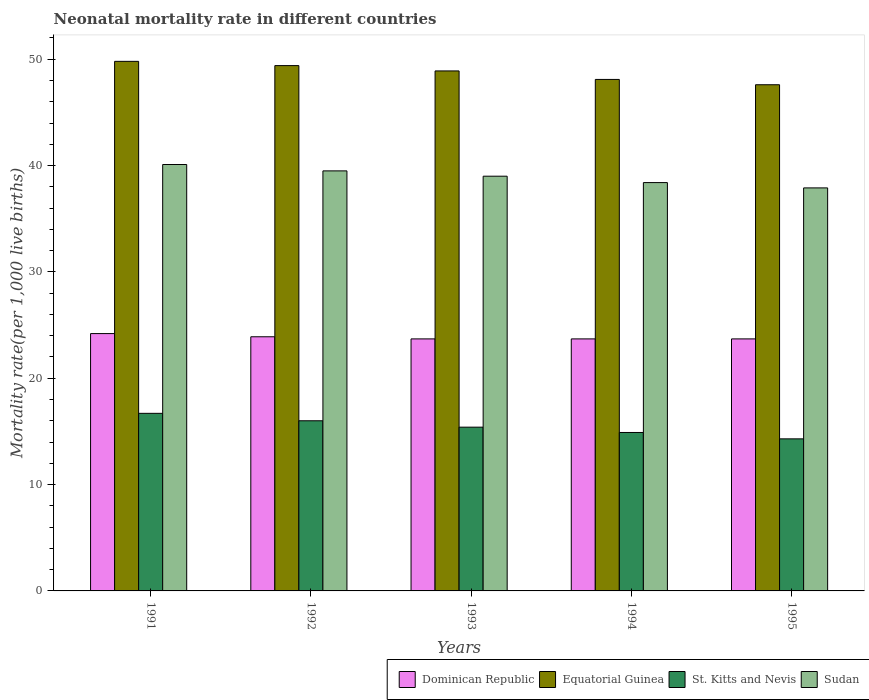How many bars are there on the 2nd tick from the left?
Ensure brevity in your answer.  4. In how many cases, is the number of bars for a given year not equal to the number of legend labels?
Your answer should be compact. 0. What is the neonatal mortality rate in Sudan in 1994?
Make the answer very short. 38.4. Across all years, what is the maximum neonatal mortality rate in Sudan?
Ensure brevity in your answer.  40.1. Across all years, what is the minimum neonatal mortality rate in Equatorial Guinea?
Offer a very short reply. 47.6. In which year was the neonatal mortality rate in St. Kitts and Nevis minimum?
Make the answer very short. 1995. What is the total neonatal mortality rate in Equatorial Guinea in the graph?
Make the answer very short. 243.8. What is the difference between the neonatal mortality rate in St. Kitts and Nevis in 1992 and that in 1995?
Offer a terse response. 1.7. What is the difference between the neonatal mortality rate in Sudan in 1991 and the neonatal mortality rate in Equatorial Guinea in 1994?
Provide a short and direct response. -8. What is the average neonatal mortality rate in Sudan per year?
Provide a succinct answer. 38.98. In the year 1993, what is the difference between the neonatal mortality rate in Dominican Republic and neonatal mortality rate in Equatorial Guinea?
Provide a short and direct response. -25.2. In how many years, is the neonatal mortality rate in Sudan greater than 28?
Your response must be concise. 5. What is the ratio of the neonatal mortality rate in Equatorial Guinea in 1992 to that in 1993?
Give a very brief answer. 1.01. Is the neonatal mortality rate in Dominican Republic in 1991 less than that in 1993?
Your answer should be very brief. No. What is the difference between the highest and the second highest neonatal mortality rate in Sudan?
Your response must be concise. 0.6. What is the difference between the highest and the lowest neonatal mortality rate in Sudan?
Keep it short and to the point. 2.2. Is the sum of the neonatal mortality rate in Dominican Republic in 1993 and 1994 greater than the maximum neonatal mortality rate in St. Kitts and Nevis across all years?
Provide a short and direct response. Yes. Is it the case that in every year, the sum of the neonatal mortality rate in St. Kitts and Nevis and neonatal mortality rate in Sudan is greater than the sum of neonatal mortality rate in Dominican Republic and neonatal mortality rate in Equatorial Guinea?
Your answer should be very brief. No. What does the 4th bar from the left in 1995 represents?
Give a very brief answer. Sudan. What does the 2nd bar from the right in 1995 represents?
Offer a very short reply. St. Kitts and Nevis. How many bars are there?
Ensure brevity in your answer.  20. Are all the bars in the graph horizontal?
Give a very brief answer. No. Does the graph contain any zero values?
Provide a short and direct response. No. Does the graph contain grids?
Your response must be concise. No. Where does the legend appear in the graph?
Your answer should be compact. Bottom right. What is the title of the graph?
Your answer should be compact. Neonatal mortality rate in different countries. Does "Sint Maarten (Dutch part)" appear as one of the legend labels in the graph?
Your answer should be compact. No. What is the label or title of the Y-axis?
Your response must be concise. Mortality rate(per 1,0 live births). What is the Mortality rate(per 1,000 live births) of Dominican Republic in 1991?
Keep it short and to the point. 24.2. What is the Mortality rate(per 1,000 live births) of Equatorial Guinea in 1991?
Make the answer very short. 49.8. What is the Mortality rate(per 1,000 live births) of Sudan in 1991?
Your response must be concise. 40.1. What is the Mortality rate(per 1,000 live births) of Dominican Republic in 1992?
Give a very brief answer. 23.9. What is the Mortality rate(per 1,000 live births) of Equatorial Guinea in 1992?
Your answer should be very brief. 49.4. What is the Mortality rate(per 1,000 live births) in St. Kitts and Nevis in 1992?
Your response must be concise. 16. What is the Mortality rate(per 1,000 live births) of Sudan in 1992?
Your answer should be very brief. 39.5. What is the Mortality rate(per 1,000 live births) in Dominican Republic in 1993?
Your answer should be compact. 23.7. What is the Mortality rate(per 1,000 live births) in Equatorial Guinea in 1993?
Give a very brief answer. 48.9. What is the Mortality rate(per 1,000 live births) of Dominican Republic in 1994?
Make the answer very short. 23.7. What is the Mortality rate(per 1,000 live births) in Equatorial Guinea in 1994?
Ensure brevity in your answer.  48.1. What is the Mortality rate(per 1,000 live births) of St. Kitts and Nevis in 1994?
Keep it short and to the point. 14.9. What is the Mortality rate(per 1,000 live births) in Sudan in 1994?
Offer a terse response. 38.4. What is the Mortality rate(per 1,000 live births) in Dominican Republic in 1995?
Keep it short and to the point. 23.7. What is the Mortality rate(per 1,000 live births) of Equatorial Guinea in 1995?
Your answer should be compact. 47.6. What is the Mortality rate(per 1,000 live births) of St. Kitts and Nevis in 1995?
Make the answer very short. 14.3. What is the Mortality rate(per 1,000 live births) in Sudan in 1995?
Your answer should be very brief. 37.9. Across all years, what is the maximum Mortality rate(per 1,000 live births) of Dominican Republic?
Offer a terse response. 24.2. Across all years, what is the maximum Mortality rate(per 1,000 live births) in Equatorial Guinea?
Give a very brief answer. 49.8. Across all years, what is the maximum Mortality rate(per 1,000 live births) in St. Kitts and Nevis?
Give a very brief answer. 16.7. Across all years, what is the maximum Mortality rate(per 1,000 live births) of Sudan?
Your answer should be very brief. 40.1. Across all years, what is the minimum Mortality rate(per 1,000 live births) in Dominican Republic?
Ensure brevity in your answer.  23.7. Across all years, what is the minimum Mortality rate(per 1,000 live births) in Equatorial Guinea?
Provide a succinct answer. 47.6. Across all years, what is the minimum Mortality rate(per 1,000 live births) of Sudan?
Give a very brief answer. 37.9. What is the total Mortality rate(per 1,000 live births) in Dominican Republic in the graph?
Make the answer very short. 119.2. What is the total Mortality rate(per 1,000 live births) in Equatorial Guinea in the graph?
Provide a short and direct response. 243.8. What is the total Mortality rate(per 1,000 live births) of St. Kitts and Nevis in the graph?
Your answer should be very brief. 77.3. What is the total Mortality rate(per 1,000 live births) of Sudan in the graph?
Provide a succinct answer. 194.9. What is the difference between the Mortality rate(per 1,000 live births) in Dominican Republic in 1991 and that in 1992?
Provide a succinct answer. 0.3. What is the difference between the Mortality rate(per 1,000 live births) in St. Kitts and Nevis in 1991 and that in 1992?
Provide a succinct answer. 0.7. What is the difference between the Mortality rate(per 1,000 live births) of Dominican Republic in 1991 and that in 1993?
Your response must be concise. 0.5. What is the difference between the Mortality rate(per 1,000 live births) of St. Kitts and Nevis in 1991 and that in 1993?
Offer a very short reply. 1.3. What is the difference between the Mortality rate(per 1,000 live births) of Dominican Republic in 1991 and that in 1994?
Provide a succinct answer. 0.5. What is the difference between the Mortality rate(per 1,000 live births) in St. Kitts and Nevis in 1991 and that in 1994?
Offer a terse response. 1.8. What is the difference between the Mortality rate(per 1,000 live births) of Dominican Republic in 1991 and that in 1995?
Your answer should be very brief. 0.5. What is the difference between the Mortality rate(per 1,000 live births) of Equatorial Guinea in 1991 and that in 1995?
Ensure brevity in your answer.  2.2. What is the difference between the Mortality rate(per 1,000 live births) in St. Kitts and Nevis in 1991 and that in 1995?
Your answer should be very brief. 2.4. What is the difference between the Mortality rate(per 1,000 live births) of Dominican Republic in 1992 and that in 1993?
Provide a short and direct response. 0.2. What is the difference between the Mortality rate(per 1,000 live births) in Equatorial Guinea in 1992 and that in 1993?
Give a very brief answer. 0.5. What is the difference between the Mortality rate(per 1,000 live births) of Dominican Republic in 1992 and that in 1994?
Ensure brevity in your answer.  0.2. What is the difference between the Mortality rate(per 1,000 live births) of Equatorial Guinea in 1992 and that in 1994?
Give a very brief answer. 1.3. What is the difference between the Mortality rate(per 1,000 live births) of Sudan in 1992 and that in 1994?
Offer a very short reply. 1.1. What is the difference between the Mortality rate(per 1,000 live births) of Equatorial Guinea in 1992 and that in 1995?
Offer a terse response. 1.8. What is the difference between the Mortality rate(per 1,000 live births) of St. Kitts and Nevis in 1992 and that in 1995?
Offer a very short reply. 1.7. What is the difference between the Mortality rate(per 1,000 live births) of Sudan in 1992 and that in 1995?
Give a very brief answer. 1.6. What is the difference between the Mortality rate(per 1,000 live births) in Equatorial Guinea in 1993 and that in 1994?
Offer a very short reply. 0.8. What is the difference between the Mortality rate(per 1,000 live births) of St. Kitts and Nevis in 1993 and that in 1994?
Offer a terse response. 0.5. What is the difference between the Mortality rate(per 1,000 live births) of Sudan in 1993 and that in 1994?
Your response must be concise. 0.6. What is the difference between the Mortality rate(per 1,000 live births) in Dominican Republic in 1993 and that in 1995?
Keep it short and to the point. 0. What is the difference between the Mortality rate(per 1,000 live births) of Sudan in 1993 and that in 1995?
Offer a terse response. 1.1. What is the difference between the Mortality rate(per 1,000 live births) in Dominican Republic in 1994 and that in 1995?
Provide a short and direct response. 0. What is the difference between the Mortality rate(per 1,000 live births) of St. Kitts and Nevis in 1994 and that in 1995?
Offer a very short reply. 0.6. What is the difference between the Mortality rate(per 1,000 live births) in Dominican Republic in 1991 and the Mortality rate(per 1,000 live births) in Equatorial Guinea in 1992?
Offer a terse response. -25.2. What is the difference between the Mortality rate(per 1,000 live births) in Dominican Republic in 1991 and the Mortality rate(per 1,000 live births) in St. Kitts and Nevis in 1992?
Your response must be concise. 8.2. What is the difference between the Mortality rate(per 1,000 live births) in Dominican Republic in 1991 and the Mortality rate(per 1,000 live births) in Sudan in 1992?
Ensure brevity in your answer.  -15.3. What is the difference between the Mortality rate(per 1,000 live births) in Equatorial Guinea in 1991 and the Mortality rate(per 1,000 live births) in St. Kitts and Nevis in 1992?
Provide a short and direct response. 33.8. What is the difference between the Mortality rate(per 1,000 live births) in St. Kitts and Nevis in 1991 and the Mortality rate(per 1,000 live births) in Sudan in 1992?
Your response must be concise. -22.8. What is the difference between the Mortality rate(per 1,000 live births) in Dominican Republic in 1991 and the Mortality rate(per 1,000 live births) in Equatorial Guinea in 1993?
Provide a succinct answer. -24.7. What is the difference between the Mortality rate(per 1,000 live births) in Dominican Republic in 1991 and the Mortality rate(per 1,000 live births) in St. Kitts and Nevis in 1993?
Your answer should be very brief. 8.8. What is the difference between the Mortality rate(per 1,000 live births) in Dominican Republic in 1991 and the Mortality rate(per 1,000 live births) in Sudan in 1993?
Keep it short and to the point. -14.8. What is the difference between the Mortality rate(per 1,000 live births) of Equatorial Guinea in 1991 and the Mortality rate(per 1,000 live births) of St. Kitts and Nevis in 1993?
Your answer should be compact. 34.4. What is the difference between the Mortality rate(per 1,000 live births) in Equatorial Guinea in 1991 and the Mortality rate(per 1,000 live births) in Sudan in 1993?
Give a very brief answer. 10.8. What is the difference between the Mortality rate(per 1,000 live births) in St. Kitts and Nevis in 1991 and the Mortality rate(per 1,000 live births) in Sudan in 1993?
Your answer should be very brief. -22.3. What is the difference between the Mortality rate(per 1,000 live births) in Dominican Republic in 1991 and the Mortality rate(per 1,000 live births) in Equatorial Guinea in 1994?
Provide a succinct answer. -23.9. What is the difference between the Mortality rate(per 1,000 live births) of Dominican Republic in 1991 and the Mortality rate(per 1,000 live births) of Sudan in 1994?
Offer a very short reply. -14.2. What is the difference between the Mortality rate(per 1,000 live births) in Equatorial Guinea in 1991 and the Mortality rate(per 1,000 live births) in St. Kitts and Nevis in 1994?
Your answer should be compact. 34.9. What is the difference between the Mortality rate(per 1,000 live births) in St. Kitts and Nevis in 1991 and the Mortality rate(per 1,000 live births) in Sudan in 1994?
Make the answer very short. -21.7. What is the difference between the Mortality rate(per 1,000 live births) of Dominican Republic in 1991 and the Mortality rate(per 1,000 live births) of Equatorial Guinea in 1995?
Provide a succinct answer. -23.4. What is the difference between the Mortality rate(per 1,000 live births) of Dominican Republic in 1991 and the Mortality rate(per 1,000 live births) of Sudan in 1995?
Offer a terse response. -13.7. What is the difference between the Mortality rate(per 1,000 live births) in Equatorial Guinea in 1991 and the Mortality rate(per 1,000 live births) in St. Kitts and Nevis in 1995?
Give a very brief answer. 35.5. What is the difference between the Mortality rate(per 1,000 live births) of St. Kitts and Nevis in 1991 and the Mortality rate(per 1,000 live births) of Sudan in 1995?
Offer a very short reply. -21.2. What is the difference between the Mortality rate(per 1,000 live births) of Dominican Republic in 1992 and the Mortality rate(per 1,000 live births) of Equatorial Guinea in 1993?
Your answer should be compact. -25. What is the difference between the Mortality rate(per 1,000 live births) in Dominican Republic in 1992 and the Mortality rate(per 1,000 live births) in Sudan in 1993?
Make the answer very short. -15.1. What is the difference between the Mortality rate(per 1,000 live births) in St. Kitts and Nevis in 1992 and the Mortality rate(per 1,000 live births) in Sudan in 1993?
Provide a succinct answer. -23. What is the difference between the Mortality rate(per 1,000 live births) of Dominican Republic in 1992 and the Mortality rate(per 1,000 live births) of Equatorial Guinea in 1994?
Your answer should be compact. -24.2. What is the difference between the Mortality rate(per 1,000 live births) of Dominican Republic in 1992 and the Mortality rate(per 1,000 live births) of St. Kitts and Nevis in 1994?
Provide a short and direct response. 9. What is the difference between the Mortality rate(per 1,000 live births) in Equatorial Guinea in 1992 and the Mortality rate(per 1,000 live births) in St. Kitts and Nevis in 1994?
Ensure brevity in your answer.  34.5. What is the difference between the Mortality rate(per 1,000 live births) in Equatorial Guinea in 1992 and the Mortality rate(per 1,000 live births) in Sudan in 1994?
Offer a very short reply. 11. What is the difference between the Mortality rate(per 1,000 live births) of St. Kitts and Nevis in 1992 and the Mortality rate(per 1,000 live births) of Sudan in 1994?
Offer a terse response. -22.4. What is the difference between the Mortality rate(per 1,000 live births) of Dominican Republic in 1992 and the Mortality rate(per 1,000 live births) of Equatorial Guinea in 1995?
Offer a terse response. -23.7. What is the difference between the Mortality rate(per 1,000 live births) of Dominican Republic in 1992 and the Mortality rate(per 1,000 live births) of St. Kitts and Nevis in 1995?
Keep it short and to the point. 9.6. What is the difference between the Mortality rate(per 1,000 live births) of Dominican Republic in 1992 and the Mortality rate(per 1,000 live births) of Sudan in 1995?
Give a very brief answer. -14. What is the difference between the Mortality rate(per 1,000 live births) in Equatorial Guinea in 1992 and the Mortality rate(per 1,000 live births) in St. Kitts and Nevis in 1995?
Provide a succinct answer. 35.1. What is the difference between the Mortality rate(per 1,000 live births) of Equatorial Guinea in 1992 and the Mortality rate(per 1,000 live births) of Sudan in 1995?
Provide a short and direct response. 11.5. What is the difference between the Mortality rate(per 1,000 live births) of St. Kitts and Nevis in 1992 and the Mortality rate(per 1,000 live births) of Sudan in 1995?
Ensure brevity in your answer.  -21.9. What is the difference between the Mortality rate(per 1,000 live births) of Dominican Republic in 1993 and the Mortality rate(per 1,000 live births) of Equatorial Guinea in 1994?
Your answer should be compact. -24.4. What is the difference between the Mortality rate(per 1,000 live births) of Dominican Republic in 1993 and the Mortality rate(per 1,000 live births) of Sudan in 1994?
Offer a terse response. -14.7. What is the difference between the Mortality rate(per 1,000 live births) in Equatorial Guinea in 1993 and the Mortality rate(per 1,000 live births) in Sudan in 1994?
Your answer should be compact. 10.5. What is the difference between the Mortality rate(per 1,000 live births) of St. Kitts and Nevis in 1993 and the Mortality rate(per 1,000 live births) of Sudan in 1994?
Give a very brief answer. -23. What is the difference between the Mortality rate(per 1,000 live births) of Dominican Republic in 1993 and the Mortality rate(per 1,000 live births) of Equatorial Guinea in 1995?
Make the answer very short. -23.9. What is the difference between the Mortality rate(per 1,000 live births) of Dominican Republic in 1993 and the Mortality rate(per 1,000 live births) of St. Kitts and Nevis in 1995?
Ensure brevity in your answer.  9.4. What is the difference between the Mortality rate(per 1,000 live births) of Dominican Republic in 1993 and the Mortality rate(per 1,000 live births) of Sudan in 1995?
Your answer should be very brief. -14.2. What is the difference between the Mortality rate(per 1,000 live births) of Equatorial Guinea in 1993 and the Mortality rate(per 1,000 live births) of St. Kitts and Nevis in 1995?
Offer a terse response. 34.6. What is the difference between the Mortality rate(per 1,000 live births) of St. Kitts and Nevis in 1993 and the Mortality rate(per 1,000 live births) of Sudan in 1995?
Keep it short and to the point. -22.5. What is the difference between the Mortality rate(per 1,000 live births) of Dominican Republic in 1994 and the Mortality rate(per 1,000 live births) of Equatorial Guinea in 1995?
Your response must be concise. -23.9. What is the difference between the Mortality rate(per 1,000 live births) of Dominican Republic in 1994 and the Mortality rate(per 1,000 live births) of St. Kitts and Nevis in 1995?
Offer a very short reply. 9.4. What is the difference between the Mortality rate(per 1,000 live births) of Dominican Republic in 1994 and the Mortality rate(per 1,000 live births) of Sudan in 1995?
Your response must be concise. -14.2. What is the difference between the Mortality rate(per 1,000 live births) in Equatorial Guinea in 1994 and the Mortality rate(per 1,000 live births) in St. Kitts and Nevis in 1995?
Give a very brief answer. 33.8. What is the difference between the Mortality rate(per 1,000 live births) in Equatorial Guinea in 1994 and the Mortality rate(per 1,000 live births) in Sudan in 1995?
Keep it short and to the point. 10.2. What is the difference between the Mortality rate(per 1,000 live births) in St. Kitts and Nevis in 1994 and the Mortality rate(per 1,000 live births) in Sudan in 1995?
Offer a terse response. -23. What is the average Mortality rate(per 1,000 live births) of Dominican Republic per year?
Make the answer very short. 23.84. What is the average Mortality rate(per 1,000 live births) of Equatorial Guinea per year?
Provide a short and direct response. 48.76. What is the average Mortality rate(per 1,000 live births) of St. Kitts and Nevis per year?
Provide a succinct answer. 15.46. What is the average Mortality rate(per 1,000 live births) in Sudan per year?
Provide a short and direct response. 38.98. In the year 1991, what is the difference between the Mortality rate(per 1,000 live births) of Dominican Republic and Mortality rate(per 1,000 live births) of Equatorial Guinea?
Give a very brief answer. -25.6. In the year 1991, what is the difference between the Mortality rate(per 1,000 live births) in Dominican Republic and Mortality rate(per 1,000 live births) in Sudan?
Provide a succinct answer. -15.9. In the year 1991, what is the difference between the Mortality rate(per 1,000 live births) of Equatorial Guinea and Mortality rate(per 1,000 live births) of St. Kitts and Nevis?
Keep it short and to the point. 33.1. In the year 1991, what is the difference between the Mortality rate(per 1,000 live births) in Equatorial Guinea and Mortality rate(per 1,000 live births) in Sudan?
Provide a succinct answer. 9.7. In the year 1991, what is the difference between the Mortality rate(per 1,000 live births) in St. Kitts and Nevis and Mortality rate(per 1,000 live births) in Sudan?
Your answer should be compact. -23.4. In the year 1992, what is the difference between the Mortality rate(per 1,000 live births) of Dominican Republic and Mortality rate(per 1,000 live births) of Equatorial Guinea?
Provide a short and direct response. -25.5. In the year 1992, what is the difference between the Mortality rate(per 1,000 live births) in Dominican Republic and Mortality rate(per 1,000 live births) in Sudan?
Ensure brevity in your answer.  -15.6. In the year 1992, what is the difference between the Mortality rate(per 1,000 live births) in Equatorial Guinea and Mortality rate(per 1,000 live births) in St. Kitts and Nevis?
Give a very brief answer. 33.4. In the year 1992, what is the difference between the Mortality rate(per 1,000 live births) of St. Kitts and Nevis and Mortality rate(per 1,000 live births) of Sudan?
Keep it short and to the point. -23.5. In the year 1993, what is the difference between the Mortality rate(per 1,000 live births) in Dominican Republic and Mortality rate(per 1,000 live births) in Equatorial Guinea?
Provide a succinct answer. -25.2. In the year 1993, what is the difference between the Mortality rate(per 1,000 live births) of Dominican Republic and Mortality rate(per 1,000 live births) of Sudan?
Give a very brief answer. -15.3. In the year 1993, what is the difference between the Mortality rate(per 1,000 live births) of Equatorial Guinea and Mortality rate(per 1,000 live births) of St. Kitts and Nevis?
Ensure brevity in your answer.  33.5. In the year 1993, what is the difference between the Mortality rate(per 1,000 live births) of Equatorial Guinea and Mortality rate(per 1,000 live births) of Sudan?
Provide a succinct answer. 9.9. In the year 1993, what is the difference between the Mortality rate(per 1,000 live births) of St. Kitts and Nevis and Mortality rate(per 1,000 live births) of Sudan?
Offer a terse response. -23.6. In the year 1994, what is the difference between the Mortality rate(per 1,000 live births) in Dominican Republic and Mortality rate(per 1,000 live births) in Equatorial Guinea?
Your response must be concise. -24.4. In the year 1994, what is the difference between the Mortality rate(per 1,000 live births) of Dominican Republic and Mortality rate(per 1,000 live births) of St. Kitts and Nevis?
Provide a succinct answer. 8.8. In the year 1994, what is the difference between the Mortality rate(per 1,000 live births) in Dominican Republic and Mortality rate(per 1,000 live births) in Sudan?
Your answer should be very brief. -14.7. In the year 1994, what is the difference between the Mortality rate(per 1,000 live births) of Equatorial Guinea and Mortality rate(per 1,000 live births) of St. Kitts and Nevis?
Provide a succinct answer. 33.2. In the year 1994, what is the difference between the Mortality rate(per 1,000 live births) in St. Kitts and Nevis and Mortality rate(per 1,000 live births) in Sudan?
Offer a terse response. -23.5. In the year 1995, what is the difference between the Mortality rate(per 1,000 live births) of Dominican Republic and Mortality rate(per 1,000 live births) of Equatorial Guinea?
Your answer should be very brief. -23.9. In the year 1995, what is the difference between the Mortality rate(per 1,000 live births) of Equatorial Guinea and Mortality rate(per 1,000 live births) of St. Kitts and Nevis?
Give a very brief answer. 33.3. In the year 1995, what is the difference between the Mortality rate(per 1,000 live births) of St. Kitts and Nevis and Mortality rate(per 1,000 live births) of Sudan?
Provide a short and direct response. -23.6. What is the ratio of the Mortality rate(per 1,000 live births) in Dominican Republic in 1991 to that in 1992?
Your answer should be compact. 1.01. What is the ratio of the Mortality rate(per 1,000 live births) in St. Kitts and Nevis in 1991 to that in 1992?
Ensure brevity in your answer.  1.04. What is the ratio of the Mortality rate(per 1,000 live births) of Sudan in 1991 to that in 1992?
Provide a succinct answer. 1.02. What is the ratio of the Mortality rate(per 1,000 live births) in Dominican Republic in 1991 to that in 1993?
Make the answer very short. 1.02. What is the ratio of the Mortality rate(per 1,000 live births) of Equatorial Guinea in 1991 to that in 1993?
Your answer should be very brief. 1.02. What is the ratio of the Mortality rate(per 1,000 live births) in St. Kitts and Nevis in 1991 to that in 1993?
Keep it short and to the point. 1.08. What is the ratio of the Mortality rate(per 1,000 live births) in Sudan in 1991 to that in 1993?
Keep it short and to the point. 1.03. What is the ratio of the Mortality rate(per 1,000 live births) of Dominican Republic in 1991 to that in 1994?
Provide a succinct answer. 1.02. What is the ratio of the Mortality rate(per 1,000 live births) of Equatorial Guinea in 1991 to that in 1994?
Offer a terse response. 1.04. What is the ratio of the Mortality rate(per 1,000 live births) in St. Kitts and Nevis in 1991 to that in 1994?
Your answer should be very brief. 1.12. What is the ratio of the Mortality rate(per 1,000 live births) in Sudan in 1991 to that in 1994?
Offer a terse response. 1.04. What is the ratio of the Mortality rate(per 1,000 live births) in Dominican Republic in 1991 to that in 1995?
Give a very brief answer. 1.02. What is the ratio of the Mortality rate(per 1,000 live births) in Equatorial Guinea in 1991 to that in 1995?
Give a very brief answer. 1.05. What is the ratio of the Mortality rate(per 1,000 live births) of St. Kitts and Nevis in 1991 to that in 1995?
Your response must be concise. 1.17. What is the ratio of the Mortality rate(per 1,000 live births) of Sudan in 1991 to that in 1995?
Ensure brevity in your answer.  1.06. What is the ratio of the Mortality rate(per 1,000 live births) in Dominican Republic in 1992 to that in 1993?
Make the answer very short. 1.01. What is the ratio of the Mortality rate(per 1,000 live births) of Equatorial Guinea in 1992 to that in 1993?
Make the answer very short. 1.01. What is the ratio of the Mortality rate(per 1,000 live births) in St. Kitts and Nevis in 1992 to that in 1993?
Your answer should be compact. 1.04. What is the ratio of the Mortality rate(per 1,000 live births) of Sudan in 1992 to that in 1993?
Provide a short and direct response. 1.01. What is the ratio of the Mortality rate(per 1,000 live births) of Dominican Republic in 1992 to that in 1994?
Offer a very short reply. 1.01. What is the ratio of the Mortality rate(per 1,000 live births) of St. Kitts and Nevis in 1992 to that in 1994?
Make the answer very short. 1.07. What is the ratio of the Mortality rate(per 1,000 live births) of Sudan in 1992 to that in 1994?
Your response must be concise. 1.03. What is the ratio of the Mortality rate(per 1,000 live births) in Dominican Republic in 1992 to that in 1995?
Ensure brevity in your answer.  1.01. What is the ratio of the Mortality rate(per 1,000 live births) of Equatorial Guinea in 1992 to that in 1995?
Give a very brief answer. 1.04. What is the ratio of the Mortality rate(per 1,000 live births) in St. Kitts and Nevis in 1992 to that in 1995?
Provide a short and direct response. 1.12. What is the ratio of the Mortality rate(per 1,000 live births) in Sudan in 1992 to that in 1995?
Your answer should be very brief. 1.04. What is the ratio of the Mortality rate(per 1,000 live births) in Dominican Republic in 1993 to that in 1994?
Ensure brevity in your answer.  1. What is the ratio of the Mortality rate(per 1,000 live births) in Equatorial Guinea in 1993 to that in 1994?
Give a very brief answer. 1.02. What is the ratio of the Mortality rate(per 1,000 live births) in St. Kitts and Nevis in 1993 to that in 1994?
Offer a terse response. 1.03. What is the ratio of the Mortality rate(per 1,000 live births) of Sudan in 1993 to that in 1994?
Your response must be concise. 1.02. What is the ratio of the Mortality rate(per 1,000 live births) in Equatorial Guinea in 1993 to that in 1995?
Your answer should be compact. 1.03. What is the ratio of the Mortality rate(per 1,000 live births) of St. Kitts and Nevis in 1993 to that in 1995?
Keep it short and to the point. 1.08. What is the ratio of the Mortality rate(per 1,000 live births) in Sudan in 1993 to that in 1995?
Your answer should be very brief. 1.03. What is the ratio of the Mortality rate(per 1,000 live births) in Equatorial Guinea in 1994 to that in 1995?
Your answer should be very brief. 1.01. What is the ratio of the Mortality rate(per 1,000 live births) in St. Kitts and Nevis in 1994 to that in 1995?
Keep it short and to the point. 1.04. What is the ratio of the Mortality rate(per 1,000 live births) of Sudan in 1994 to that in 1995?
Keep it short and to the point. 1.01. What is the difference between the highest and the second highest Mortality rate(per 1,000 live births) of Dominican Republic?
Give a very brief answer. 0.3. What is the difference between the highest and the second highest Mortality rate(per 1,000 live births) of St. Kitts and Nevis?
Provide a succinct answer. 0.7. What is the difference between the highest and the second highest Mortality rate(per 1,000 live births) in Sudan?
Your response must be concise. 0.6. What is the difference between the highest and the lowest Mortality rate(per 1,000 live births) of Dominican Republic?
Your answer should be compact. 0.5. What is the difference between the highest and the lowest Mortality rate(per 1,000 live births) of Equatorial Guinea?
Provide a short and direct response. 2.2. What is the difference between the highest and the lowest Mortality rate(per 1,000 live births) in Sudan?
Make the answer very short. 2.2. 